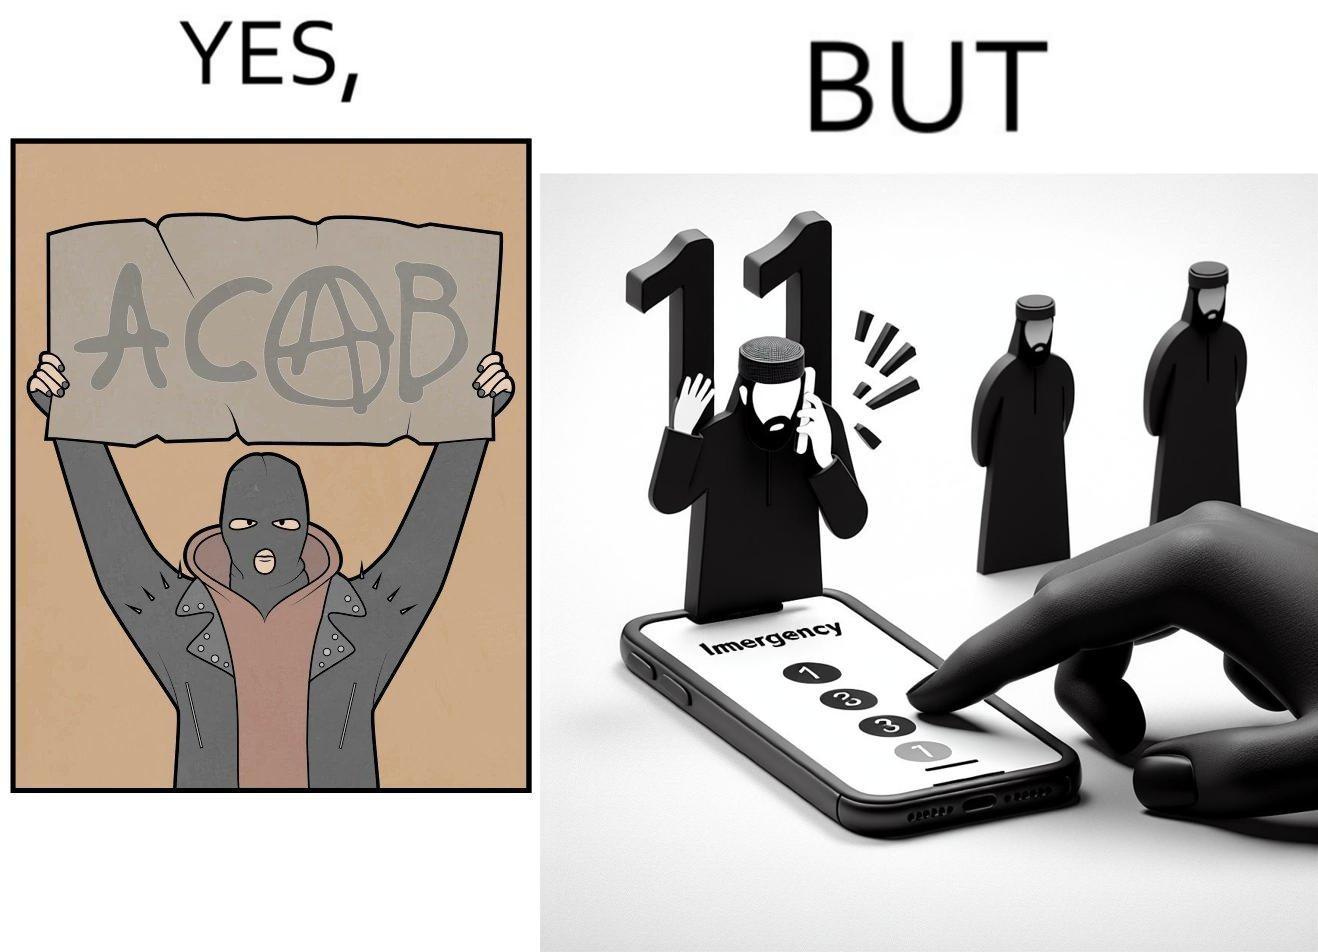Is this a satirical image? Yes, this image is satirical. 